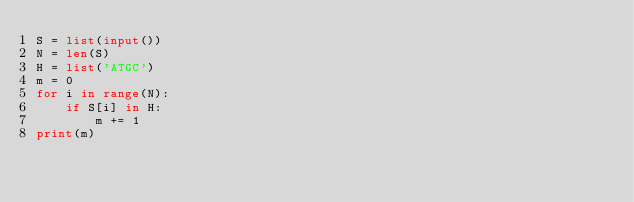<code> <loc_0><loc_0><loc_500><loc_500><_Python_>S = list(input())
N = len(S)
H = list('ATGC')
m = 0
for i in range(N):
    if S[i] in H:
        m += 1
print(m)</code> 